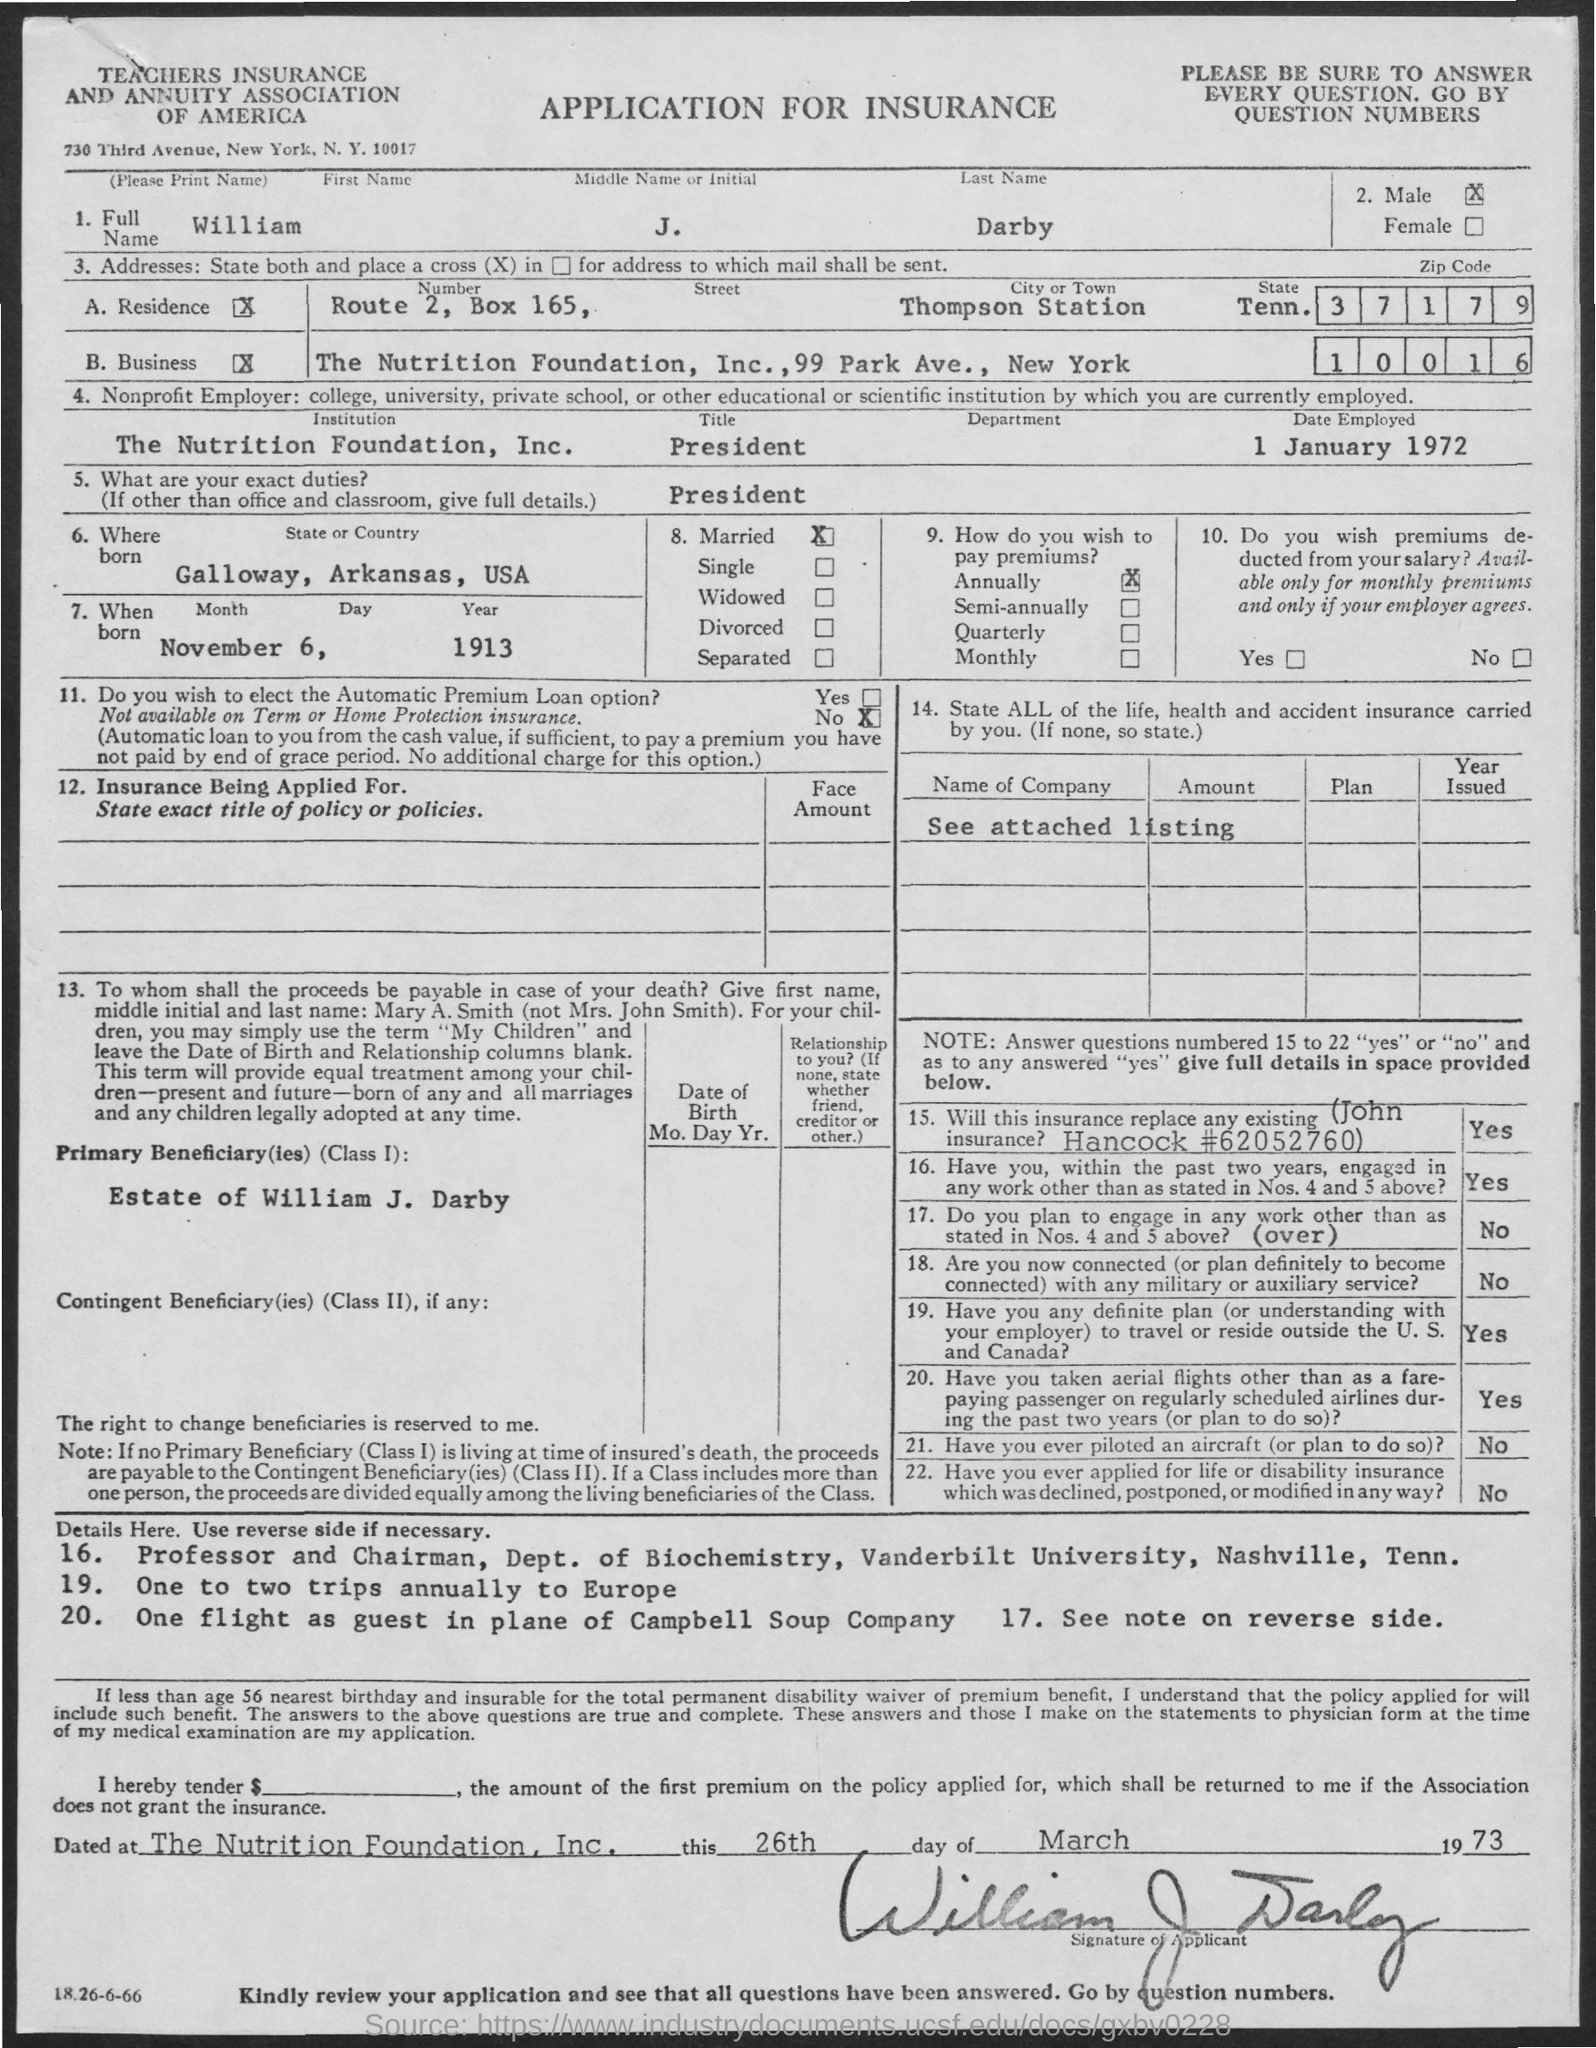What is the Full Name?
Your answer should be very brief. WILLIAM J. DARBY. What is the City or Town?
Offer a very short reply. THOMPSON STATION. Which is the Institution?
Make the answer very short. THE NUTRITION FOUNDATION, INC. What is the Title?
Ensure brevity in your answer.  President. When is the Date Employed?
Ensure brevity in your answer.  1 January 1972. Which is the State or Country he was born?
Provide a short and direct response. Galloway, Arkansas, USA. When was he born?
Offer a very short reply. November 6, 1913. How does William J. Darby wish to pay premium?
Your answer should be compact. Annually. What is the Zipcode for Residence address?
Make the answer very short. 37179. 